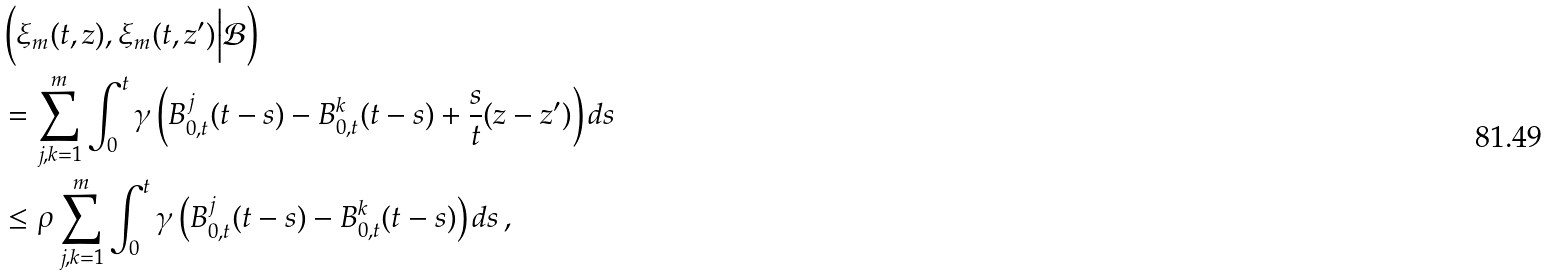<formula> <loc_0><loc_0><loc_500><loc_500>& \left ( \xi _ { m } ( t , z ) , \xi _ { m } ( t , z ^ { \prime } ) \Big | \mathcal { B } \right ) \\ & = \sum _ { j , k = 1 } ^ { m } \int _ { 0 } ^ { t } \gamma \left ( B _ { 0 , t } ^ { j } ( t - s ) - B _ { 0 , t } ^ { k } ( t - s ) + \frac { s } { t } ( z - z ^ { \prime } ) \right ) d s \\ & \leq \rho \sum _ { j , k = 1 } ^ { m } \int _ { 0 } ^ { t } \gamma \left ( B _ { 0 , t } ^ { j } ( t - s ) - B _ { 0 , t } ^ { k } ( t - s ) \right ) d s \, ,</formula> 